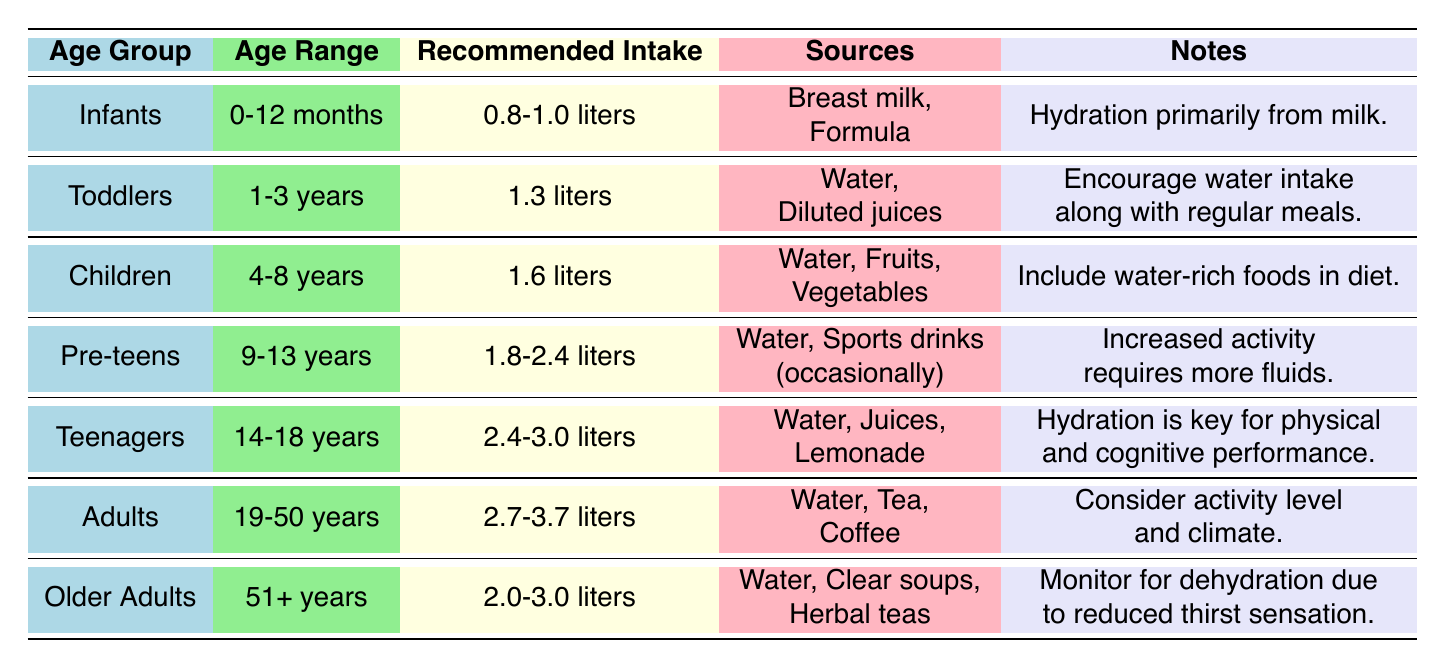What is the recommended daily water intake for toddlers? The table lists the recommended daily water intake for toddlers in the "Recommended Intake" column, indicating it is 1.3 liters.
Answer: 1.3 liters Which age group has the highest recommended daily water intake? By examining the "Recommended Intake" column, the age group "Teenagers" shows a range of 2.4-3.0 liters, which is higher than all other groups.
Answer: Teenagers Is the recommended water intake for older adults greater than that for children? Comparing the recommended intakes, older adults have 2.0-3.0 liters while children have 1.6 liters, indicating older adults' recommended intake is greater.
Answer: Yes Calculate the average recommended daily water intake for pre-teens and teenagers. The average for pre-teens is (1.8 + 2.4) / 2 = 2.1 liters, and for teenagers, it is (2.4 + 3.0) / 2 = 2.7 liters. The average of these two results is (2.1 + 2.7) / 2 = 2.4 liters.
Answer: 2.4 liters What sources of hydration are recommended for adults? The table indicates that adults should hydrate using "Water, Tea, Coffee" as listed in the "Sources" column.
Answer: Water, Tea, Coffee Do infants have a higher or lower recommended intake than toddlers? Infants have a recommended intake of 0.8-1.0 liters, which is lower than toddlers’ 1.3 liters.
Answer: Lower What is the recommended water intake for individuals aged 51 years and older? The "Recommended Intake" column lists the value for older adults as 2.0-3.0 liters for ages 51 and older, as indicated in the table.
Answer: 2.0-3.0 liters How much more water should teenagers drink than toddlers? Teenagers have a recommended intake of 2.4-3.0 liters, while toddlers have 1.3 liters. The minimum difference is 2.4 - 1.3 = 1.1 liters and the maximum is 3.0 - 1.3 = 1.7 liters, so teenagers should drink between 1.1 and 1.7 liters more than toddlers.
Answer: 1.1 to 1.7 liters Which group requires monitoring for dehydration? The notes under "Older Adults" indicate the need for monitoring dehydration due to reduced thirst sensation, which answers the question.
Answer: Older Adults 